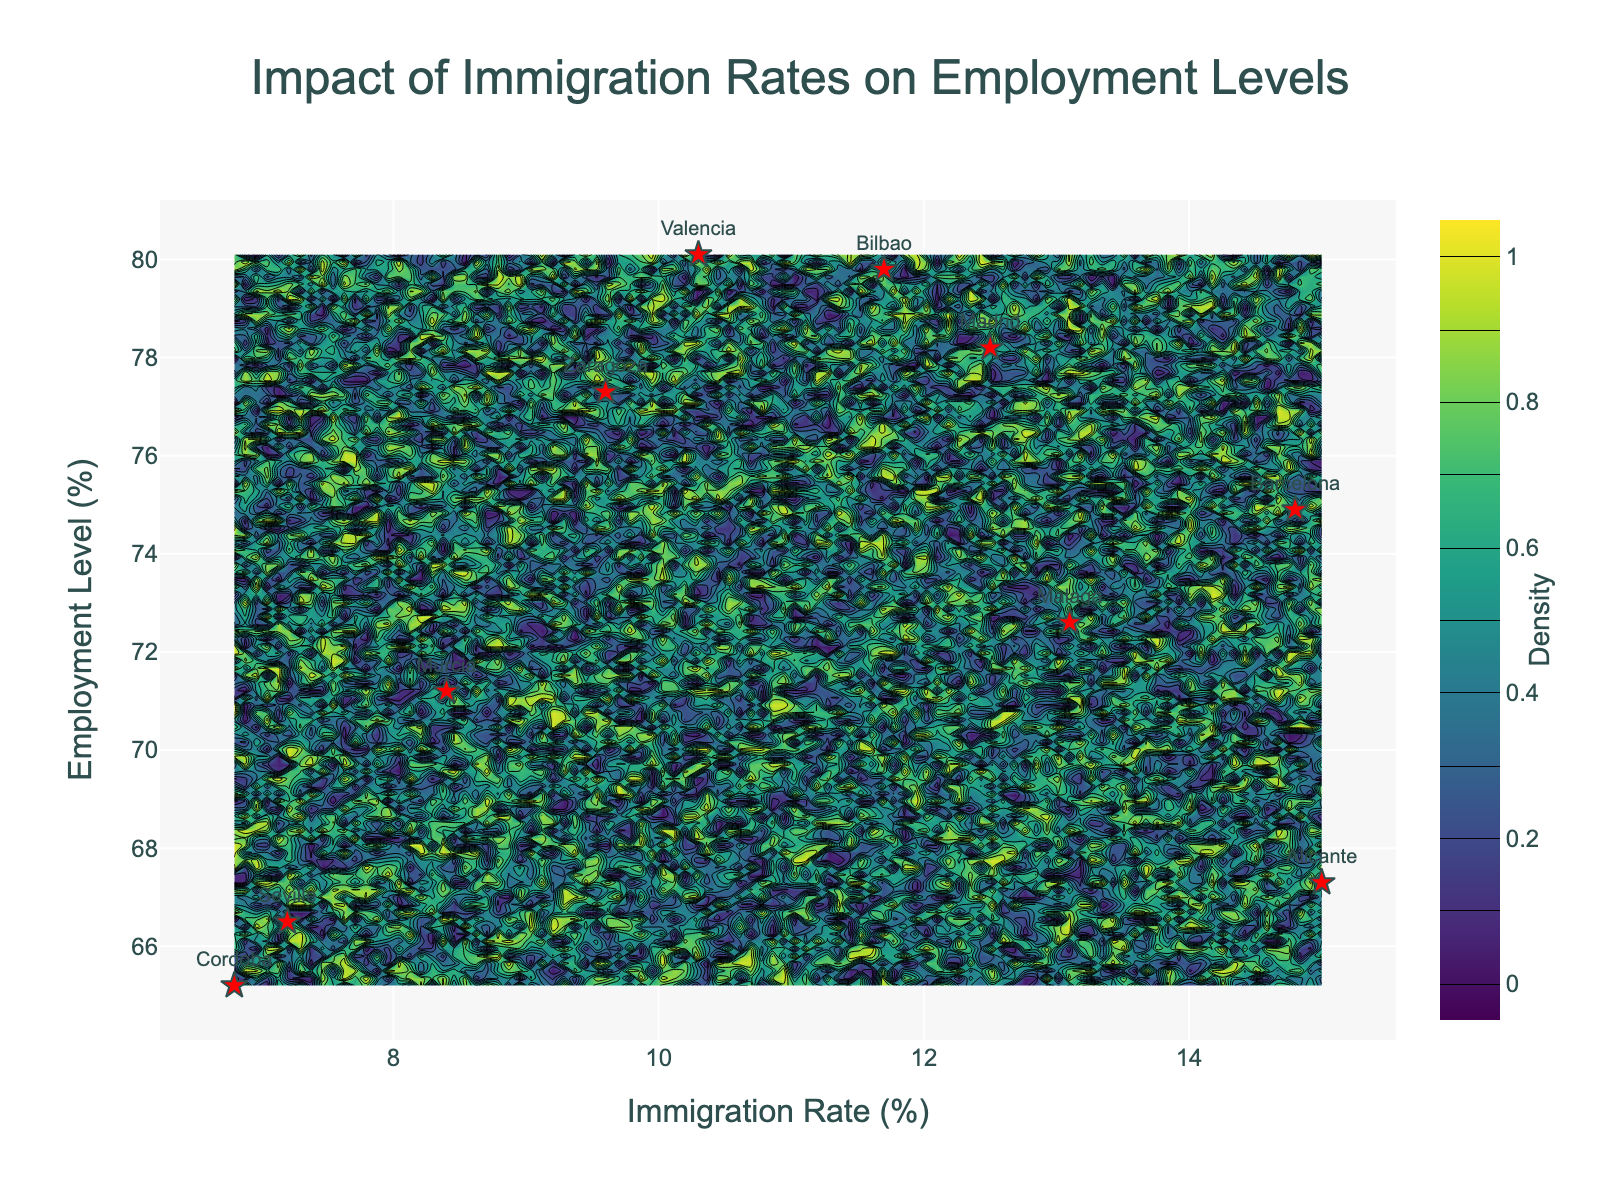What is the title of the figure? The title is often found at the top center of the figure, above the plot area. In this figure, it reads "Impact of Immigration Rates on Employment Levels."
Answer: Impact of Immigration Rates on Employment Levels What are the x-axis and y-axis labels in the figure? The x-axis and y-axis labels are typically located beneath the horizontal axis and next to the vertical axis, respectively. In this figure, the x-axis label is "Immigration Rate (%)" and the y-axis label is "Employment Level (%)."
Answer: Immigration Rate (%) and Employment Level (%) How many municipalities are represented by the red star markers in the figure? The red star markers correspond to the municipalities listed in the provided data. By counting these markers, we can determine there are 10 municipalities represented.
Answer: 10 Which municipality shows the lowest employment level in the figure? The municipality with the lowest employment level can be identified by looking for the red star marker positioned lowest on the y-axis. In this figure, Cordoba has the lowest employment level at 65.2%.
Answer: Cordoba Between Madrid and Bilbao, which municipality has a higher immigration rate? By comparing the positions of the red star markers for Madrid and Bilbao on the x-axis, we see that Madrid's marker is further to the left than Bilbao's. This indicates that Madrid has a lower immigration rate than Bilbao.
Answer: Bilbao What is the range of immigration rates shown in the figure? The range can be found by identifying the minimum and maximum positions on the x-axis where red star markers appear. In this figure, the immigration rate ranges from 6.8% (Cordoba) to 15.0% (Alicante).
Answer: 6.8% to 15.0% Which two municipalities have employment levels closest to 80%? By examining the y-axis positions of the red star markers, we see that Valencia and Bilbao both have employment levels close to 80% (80.1% for Valencia and 79.8% for Bilbao).
Answer: Valencia and Bilbao What is the median employment level among the municipalities shown in the figure? To find the median employment level, we list the employment levels in ascending order: 65.2, 66.5, 67.3, 71.2, 72.6, 74.9, 77.3, 78.2, 79.8, 80.1. With 10 values, the median is the average of the 5th and 6th values: (72.6 + 74.9)/2 = 73.75%.
Answer: 73.75% Which municipality has an immigration rate closest to the average immigration rate of all municipalities? First, calculate the average immigration rate: (12.5 + 14.8 + 10.3 + 7.2 + 9.6 + 13.1 + 8.4 + 11.7 + 15.0 + 6.8) / 10 = 10.94%. By comparing this with individual immigration rates, Zaragoza (9.6) is closest.
Answer: Zaragoza What color scheme is used for the density contours in the figure? The density contours are colored using the 'Viridis' colorscale, which typically ranges from dark blue to yellow-green. This information is visible in the figure's color bar and contour shading.
Answer: Viridis 